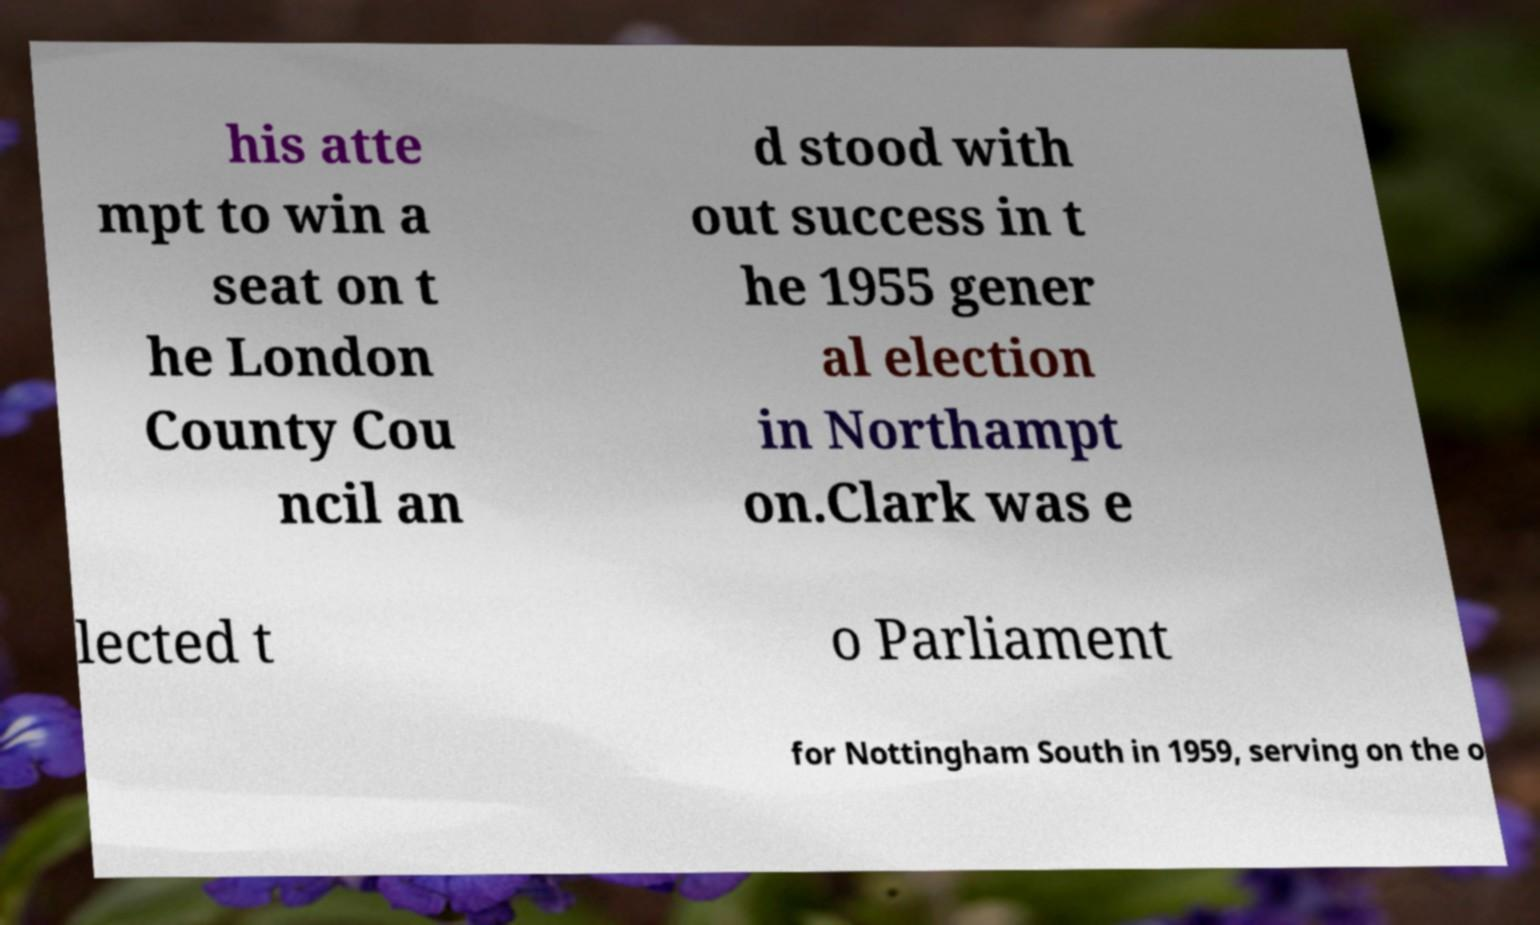For documentation purposes, I need the text within this image transcribed. Could you provide that? his atte mpt to win a seat on t he London County Cou ncil an d stood with out success in t he 1955 gener al election in Northampt on.Clark was e lected t o Parliament for Nottingham South in 1959, serving on the o 